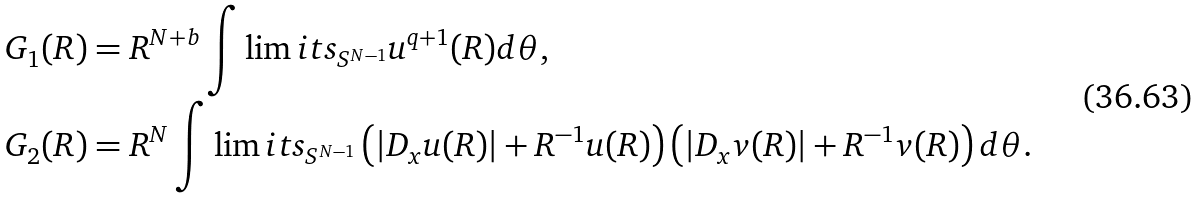Convert formula to latex. <formula><loc_0><loc_0><loc_500><loc_500>& G _ { 1 } ( R ) = R ^ { N + b } \int \lim i t s _ { S ^ { N - 1 } } u ^ { q + 1 } ( R ) d \theta , \\ & G _ { 2 } ( R ) = R ^ { N } \int \lim i t s _ { S ^ { N - 1 } } \left ( | D _ { x } u ( R ) | + R ^ { - 1 } u ( R ) \right ) \left ( | D _ { x } v ( R ) | + R ^ { - 1 } v ( R ) \right ) d \theta .</formula> 